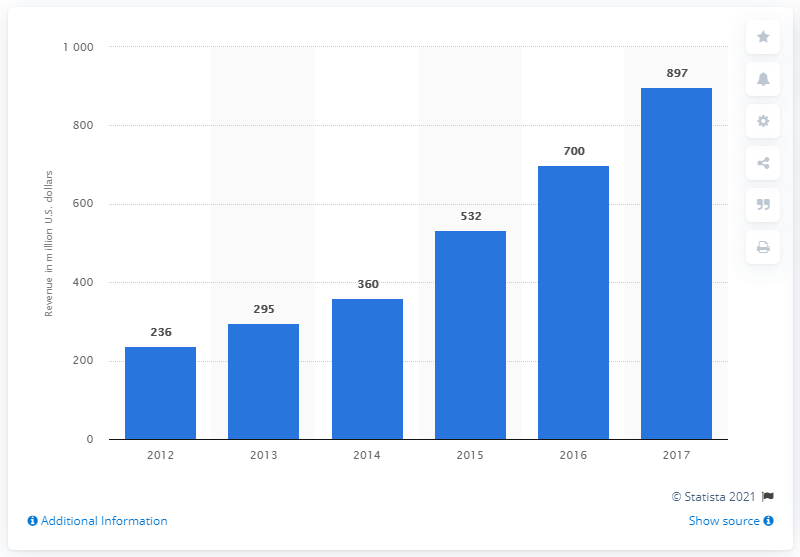Mention a couple of crucial points in this snapshot. HauteLook's total revenue in 2017 was 897 million dollars. 